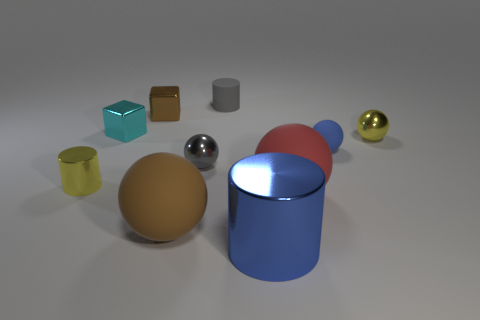How many other cylinders have the same color as the small matte cylinder?
Keep it short and to the point. 0. What number of blue cylinders are there?
Give a very brief answer. 1. What number of small cyan things are the same material as the gray cylinder?
Ensure brevity in your answer.  0. There is a brown matte thing that is the same shape as the tiny blue rubber object; what is its size?
Offer a terse response. Large. What is the material of the small cyan object?
Ensure brevity in your answer.  Metal. What material is the brown block that is behind the small yellow metallic thing behind the gray thing in front of the yellow sphere?
Give a very brief answer. Metal. Are there an equal number of gray blocks and brown rubber objects?
Provide a short and direct response. No. Is there any other thing that is the same shape as the tiny brown shiny thing?
Your answer should be very brief. Yes. There is another big matte thing that is the same shape as the large red object; what color is it?
Your answer should be compact. Brown. Does the small metal block that is behind the tiny cyan metal cube have the same color as the small cylinder that is behind the small shiny cylinder?
Ensure brevity in your answer.  No. 